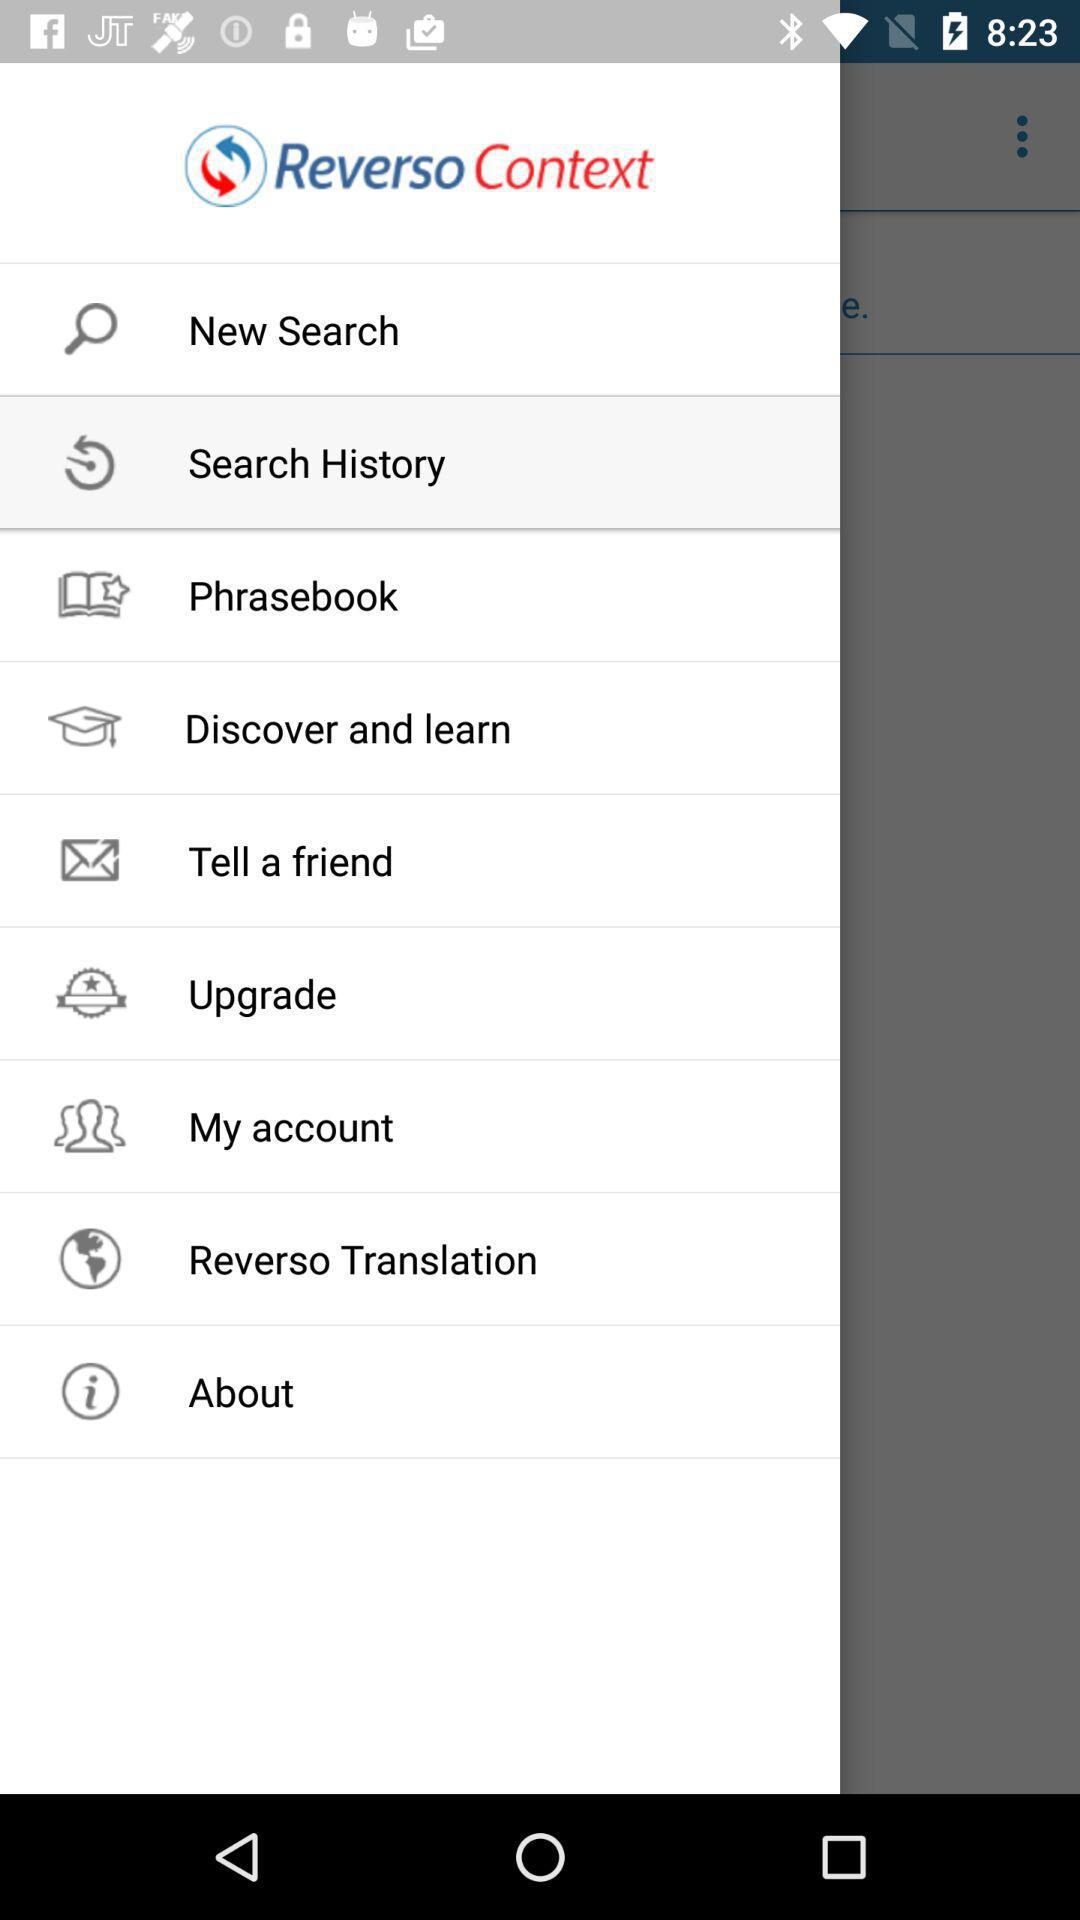Which option is currently selected? The selected option is "Search History". 